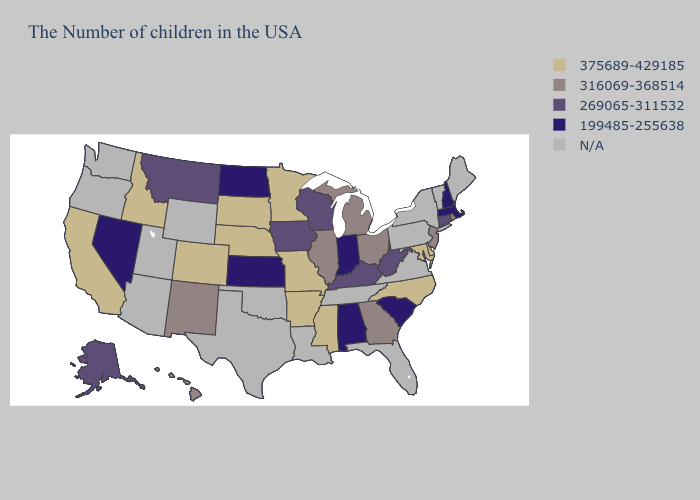Does the first symbol in the legend represent the smallest category?
Be succinct. No. Name the states that have a value in the range 375689-429185?
Write a very short answer. Delaware, Maryland, North Carolina, Mississippi, Missouri, Arkansas, Minnesota, Nebraska, South Dakota, Colorado, Idaho, California. What is the lowest value in the West?
Answer briefly. 199485-255638. What is the highest value in the USA?
Quick response, please. 375689-429185. Does the map have missing data?
Answer briefly. Yes. Which states have the highest value in the USA?
Keep it brief. Delaware, Maryland, North Carolina, Mississippi, Missouri, Arkansas, Minnesota, Nebraska, South Dakota, Colorado, Idaho, California. Which states have the lowest value in the USA?
Keep it brief. Massachusetts, New Hampshire, South Carolina, Indiana, Alabama, Kansas, North Dakota, Nevada. What is the value of Alabama?
Be succinct. 199485-255638. Does the map have missing data?
Answer briefly. Yes. What is the lowest value in states that border Georgia?
Answer briefly. 199485-255638. Name the states that have a value in the range 316069-368514?
Be succinct. Rhode Island, New Jersey, Ohio, Georgia, Michigan, Illinois, New Mexico, Hawaii. Which states hav the highest value in the West?
Keep it brief. Colorado, Idaho, California. Name the states that have a value in the range N/A?
Keep it brief. Maine, Vermont, New York, Pennsylvania, Virginia, Florida, Tennessee, Louisiana, Oklahoma, Texas, Wyoming, Utah, Arizona, Washington, Oregon. 